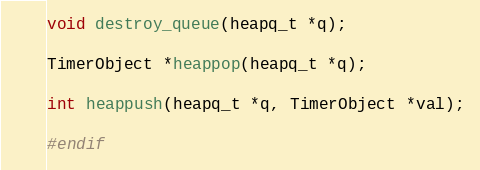<code> <loc_0><loc_0><loc_500><loc_500><_C_>void destroy_queue(heapq_t *q);

TimerObject *heappop(heapq_t *q);

int heappush(heapq_t *q, TimerObject *val);

#endif
</code> 